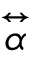<formula> <loc_0><loc_0><loc_500><loc_500>\stackrel { \leftrightarrow } { \alpha }</formula> 